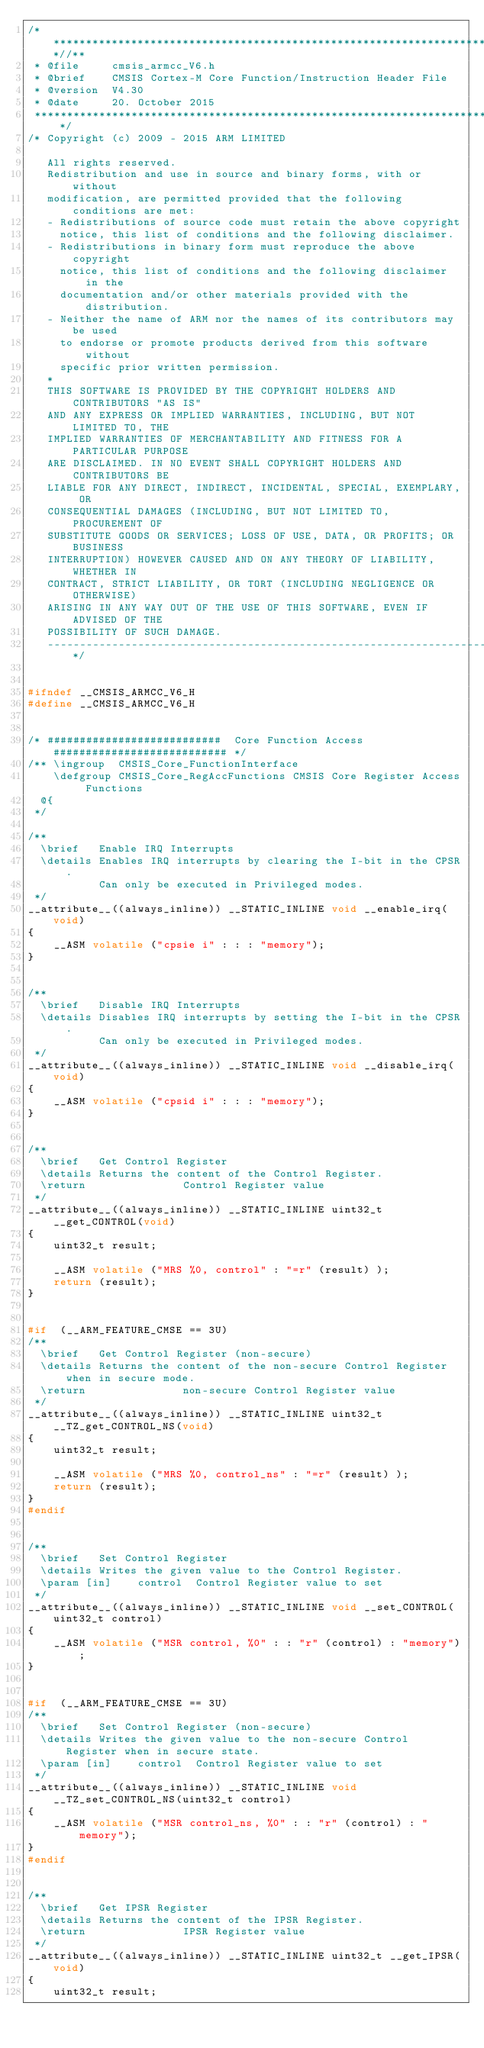Convert code to text. <code><loc_0><loc_0><loc_500><loc_500><_C_>/**************************************************************************//**
 * @file     cmsis_armcc_V6.h
 * @brief    CMSIS Cortex-M Core Function/Instruction Header File
 * @version  V4.30
 * @date     20. October 2015
 ******************************************************************************/
/* Copyright (c) 2009 - 2015 ARM LIMITED

   All rights reserved.
   Redistribution and use in source and binary forms, with or without
   modification, are permitted provided that the following conditions are met:
   - Redistributions of source code must retain the above copyright
     notice, this list of conditions and the following disclaimer.
   - Redistributions in binary form must reproduce the above copyright
     notice, this list of conditions and the following disclaimer in the
     documentation and/or other materials provided with the distribution.
   - Neither the name of ARM nor the names of its contributors may be used
     to endorse or promote products derived from this software without
     specific prior written permission.
   *
   THIS SOFTWARE IS PROVIDED BY THE COPYRIGHT HOLDERS AND CONTRIBUTORS "AS IS"
   AND ANY EXPRESS OR IMPLIED WARRANTIES, INCLUDING, BUT NOT LIMITED TO, THE
   IMPLIED WARRANTIES OF MERCHANTABILITY AND FITNESS FOR A PARTICULAR PURPOSE
   ARE DISCLAIMED. IN NO EVENT SHALL COPYRIGHT HOLDERS AND CONTRIBUTORS BE
   LIABLE FOR ANY DIRECT, INDIRECT, INCIDENTAL, SPECIAL, EXEMPLARY, OR
   CONSEQUENTIAL DAMAGES (INCLUDING, BUT NOT LIMITED TO, PROCUREMENT OF
   SUBSTITUTE GOODS OR SERVICES; LOSS OF USE, DATA, OR PROFITS; OR BUSINESS
   INTERRUPTION) HOWEVER CAUSED AND ON ANY THEORY OF LIABILITY, WHETHER IN
   CONTRACT, STRICT LIABILITY, OR TORT (INCLUDING NEGLIGENCE OR OTHERWISE)
   ARISING IN ANY WAY OUT OF THE USE OF THIS SOFTWARE, EVEN IF ADVISED OF THE
   POSSIBILITY OF SUCH DAMAGE.
   ---------------------------------------------------------------------------*/


#ifndef __CMSIS_ARMCC_V6_H
#define __CMSIS_ARMCC_V6_H


/* ###########################  Core Function Access  ########################### */
/** \ingroup  CMSIS_Core_FunctionInterface
    \defgroup CMSIS_Core_RegAccFunctions CMSIS Core Register Access Functions
  @{
 */

/**
  \brief   Enable IRQ Interrupts
  \details Enables IRQ interrupts by clearing the I-bit in the CPSR.
           Can only be executed in Privileged modes.
 */
__attribute__((always_inline)) __STATIC_INLINE void __enable_irq(void)
{
    __ASM volatile ("cpsie i" : : : "memory");
}


/**
  \brief   Disable IRQ Interrupts
  \details Disables IRQ interrupts by setting the I-bit in the CPSR.
           Can only be executed in Privileged modes.
 */
__attribute__((always_inline)) __STATIC_INLINE void __disable_irq(void)
{
    __ASM volatile ("cpsid i" : : : "memory");
}


/**
  \brief   Get Control Register
  \details Returns the content of the Control Register.
  \return               Control Register value
 */
__attribute__((always_inline)) __STATIC_INLINE uint32_t __get_CONTROL(void)
{
    uint32_t result;

    __ASM volatile ("MRS %0, control" : "=r" (result) );
    return (result);
}


#if  (__ARM_FEATURE_CMSE == 3U)
/**
  \brief   Get Control Register (non-secure)
  \details Returns the content of the non-secure Control Register when in secure mode.
  \return               non-secure Control Register value
 */
__attribute__((always_inline)) __STATIC_INLINE uint32_t __TZ_get_CONTROL_NS(void)
{
    uint32_t result;

    __ASM volatile ("MRS %0, control_ns" : "=r" (result) );
    return (result);
}
#endif


/**
  \brief   Set Control Register
  \details Writes the given value to the Control Register.
  \param [in]    control  Control Register value to set
 */
__attribute__((always_inline)) __STATIC_INLINE void __set_CONTROL(uint32_t control)
{
    __ASM volatile ("MSR control, %0" : : "r" (control) : "memory");
}


#if  (__ARM_FEATURE_CMSE == 3U)
/**
  \brief   Set Control Register (non-secure)
  \details Writes the given value to the non-secure Control Register when in secure state.
  \param [in]    control  Control Register value to set
 */
__attribute__((always_inline)) __STATIC_INLINE void __TZ_set_CONTROL_NS(uint32_t control)
{
    __ASM volatile ("MSR control_ns, %0" : : "r" (control) : "memory");
}
#endif


/**
  \brief   Get IPSR Register
  \details Returns the content of the IPSR Register.
  \return               IPSR Register value
 */
__attribute__((always_inline)) __STATIC_INLINE uint32_t __get_IPSR(void)
{
    uint32_t result;
</code> 